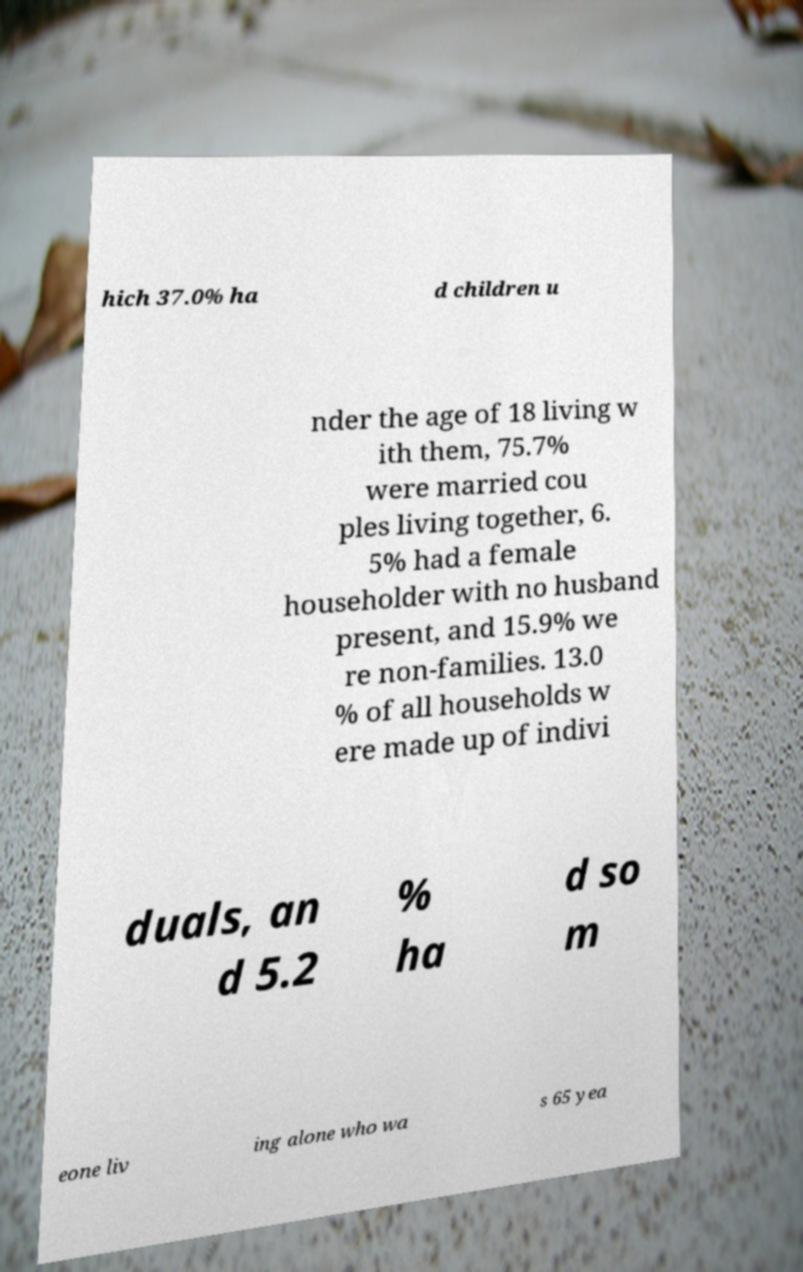Please read and relay the text visible in this image. What does it say? hich 37.0% ha d children u nder the age of 18 living w ith them, 75.7% were married cou ples living together, 6. 5% had a female householder with no husband present, and 15.9% we re non-families. 13.0 % of all households w ere made up of indivi duals, an d 5.2 % ha d so m eone liv ing alone who wa s 65 yea 